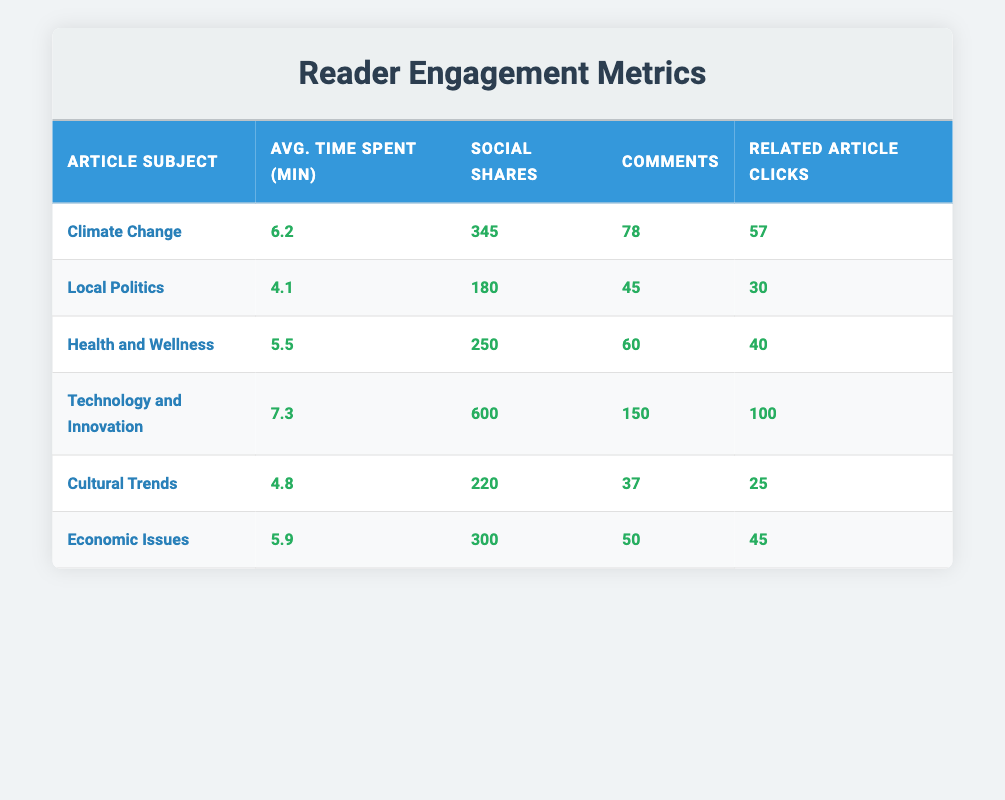What article subject has the highest average time spent? In the table, compare the "Avg. Time Spent (min)" column values for each article subject. The subject with the highest value is "Technology and Innovation" with an average time spent of 7.3 minutes.
Answer: Technology and Innovation How many social shares did "Climate Change" receive? The table shows "Climate Change" with 345 social shares listed in the "Social Shares" column.
Answer: 345 Is the average time spent on "Local Politics" greater than 5 minutes? Looking at the "Avg. Time Spent (min)" for "Local Politics," it is 4.1 minutes, which is less than 5. Thus, the answer is no.
Answer: No What is the total number of comments for "Health and Wellness" and "Economic Issues"? To find the total, add the comments for "Health and Wellness" (60) and "Economic Issues" (50). The sum is 60 + 50 = 110.
Answer: 110 Which article subject has the least number of related article clicks? Examine the "Related Article Clicks" column and find the minimum value. "Cultural Trends" has the least with 25 clicks.
Answer: Cultural Trends How many more social shares does "Technology and Innovation" have compared to "Cultural Trends"? Find the difference in social shares: "Technology and Innovation" has 600 while "Cultural Trends" has 220. The difference is 600 - 220 = 380.
Answer: 380 Is the number of clicks to related articles for "Climate Change" greater than that for "Health and Wellness"? Compare the "Related Article Clicks" for both subjects. "Climate Change" has 57 clicks and "Health and Wellness" has 40; since 57 is greater than 40, the answer is yes.
Answer: Yes What is the average of all the average times spent on the articles? Calculate the total average time spent: (6.2 + 4.1 + 5.5 + 7.3 + 4.8 + 5.9) = 33.8, and divide by the number of articles (6). The average is 33.8 / 6 = 5.6333, which rounds to 5.6 minutes.
Answer: 5.6 Which article subject received the most comments? By checking the "Comments" column, "Technology and Innovation" received the highest number with 150 comments.
Answer: Technology and Innovation 